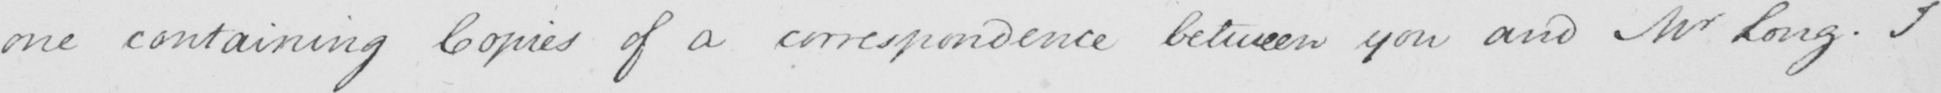Can you tell me what this handwritten text says? one containing Copies of a correspondence between you and Mr Long . I 